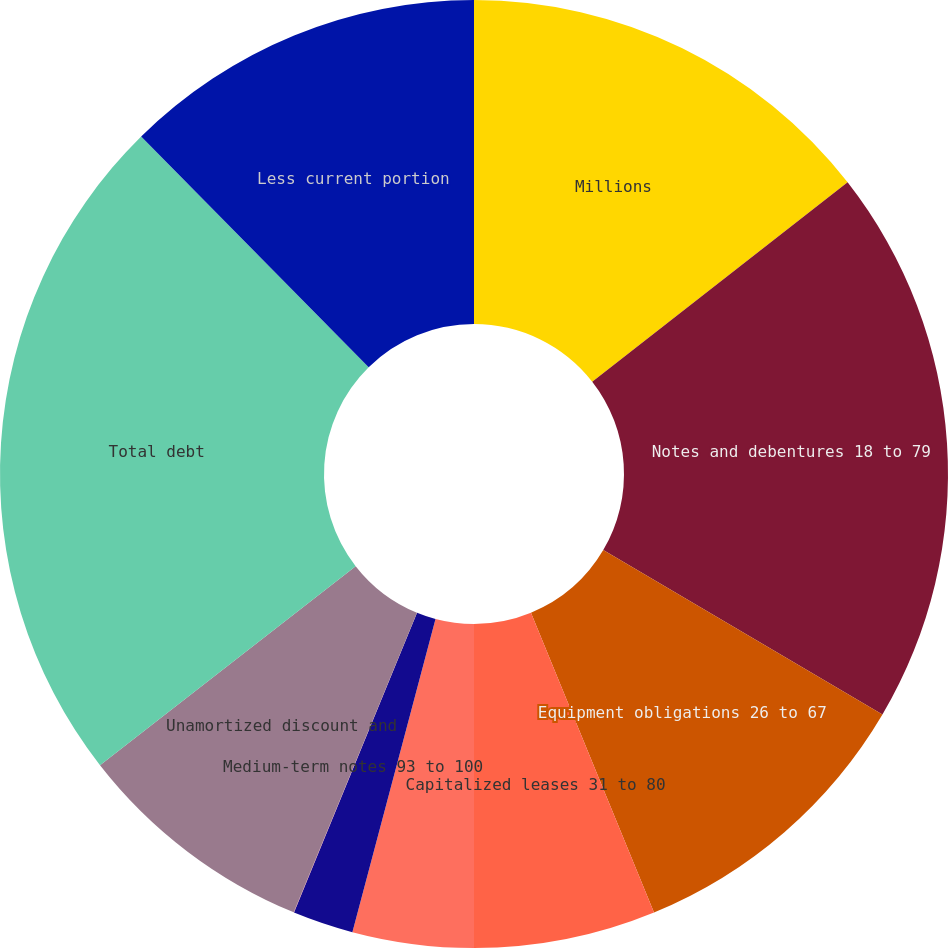Convert chart. <chart><loc_0><loc_0><loc_500><loc_500><pie_chart><fcel>Millions<fcel>Notes and debentures 18 to 79<fcel>Equipment obligations 26 to 67<fcel>Capitalized leases 31 to 80<fcel>Receivables Securitization<fcel>Term loans - floating rate due<fcel>Medium-term notes 93 to 100<fcel>Unamortized discount and<fcel>Total debt<fcel>Less current portion<nl><fcel>14.45%<fcel>19.02%<fcel>10.33%<fcel>6.2%<fcel>4.13%<fcel>2.07%<fcel>0.01%<fcel>8.26%<fcel>23.14%<fcel>12.39%<nl></chart> 